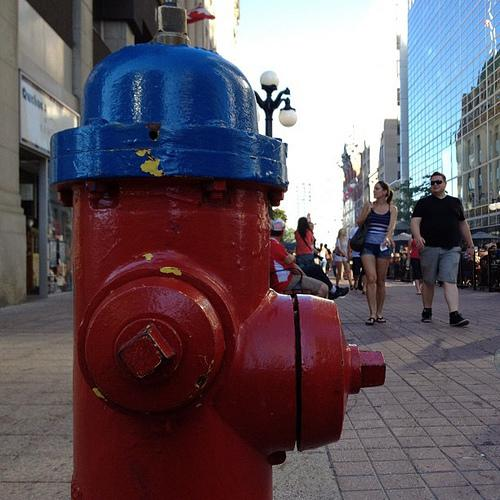Question: where was this photo taken?
Choices:
A. Outside on a city street.
B. On the front porch.
C. At the park.
D. At the beach.
Answer with the letter. Answer: A Question: what is in the foreground?
Choices:
A. A fire truck.
B. A fire hydrant.
C. A telephone pole.
D. A car.
Answer with the letter. Answer: B Question: what color is the top of the hydrant?
Choices:
A. Blue.
B. Yellow.
C. White.
D. Red.
Answer with the letter. Answer: A Question: how many bulbs are visible on the street lamp?
Choices:
A. Three.
B. One.
C. None.
D. Two.
Answer with the letter. Answer: D Question: who is walking next to the man in the sunglasses?
Choices:
A. A younger man walking a dog.
B. A woman in a blue tank top.
C. A girl in a pink shirt.
D. An older man in a polo shirt.
Answer with the letter. Answer: B Question: what time of year was the photo most likely taken?
Choices:
A. Winter.
B. Summer.
C. Spring.
D. Fall.
Answer with the letter. Answer: B 